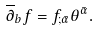Convert formula to latex. <formula><loc_0><loc_0><loc_500><loc_500>\overline { \partial } _ { b } f = f _ { ; \bar { \alpha } } \theta ^ { \bar { \alpha } } .</formula> 